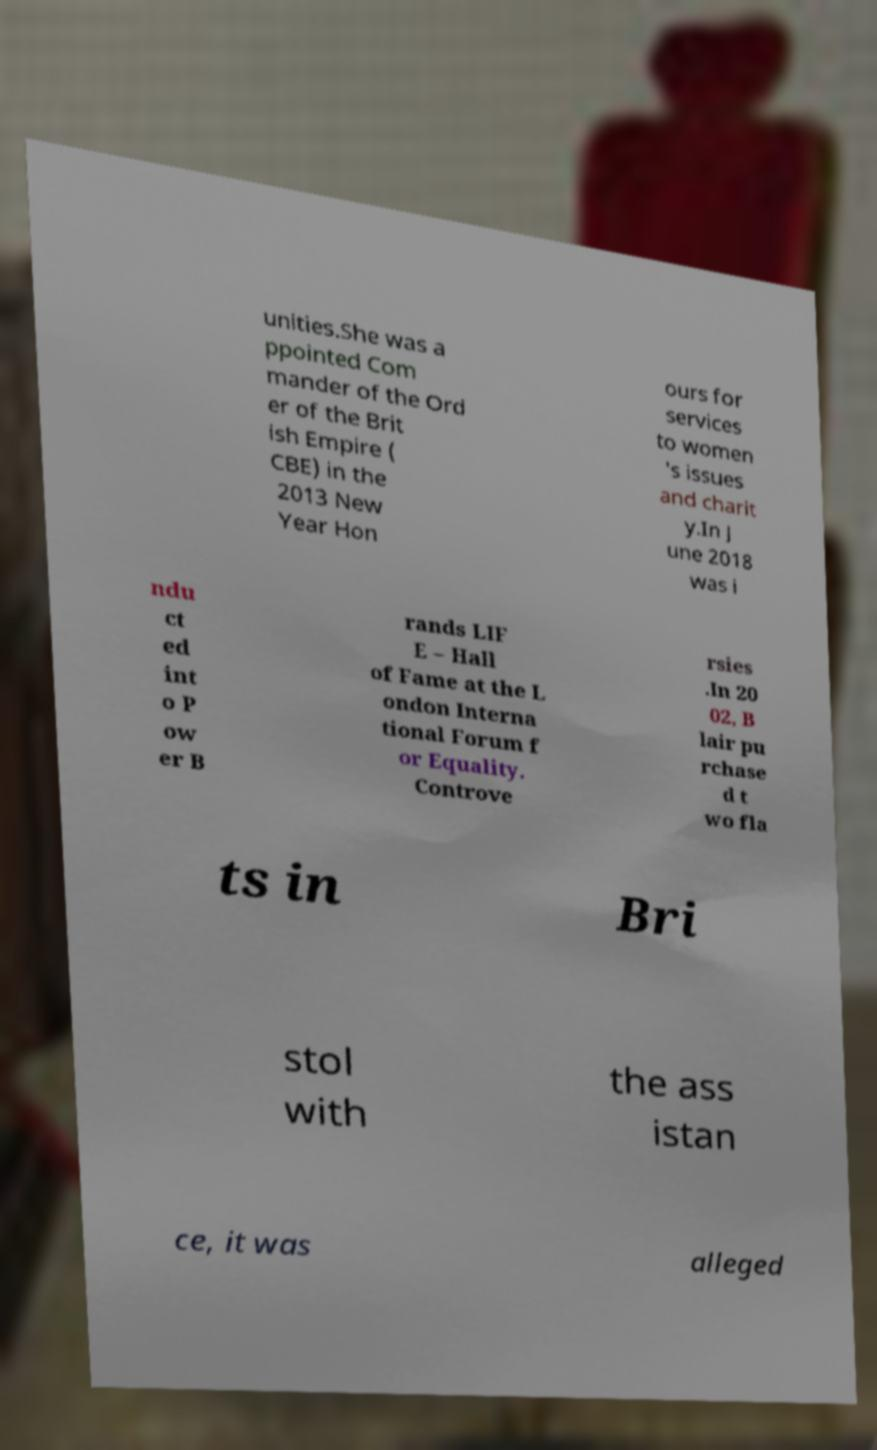I need the written content from this picture converted into text. Can you do that? unities.She was a ppointed Com mander of the Ord er of the Brit ish Empire ( CBE) in the 2013 New Year Hon ours for services to women 's issues and charit y.In J une 2018 was i ndu ct ed int o P ow er B rands LIF E – Hall of Fame at the L ondon Interna tional Forum f or Equality. Controve rsies .In 20 02, B lair pu rchase d t wo fla ts in Bri stol with the ass istan ce, it was alleged 